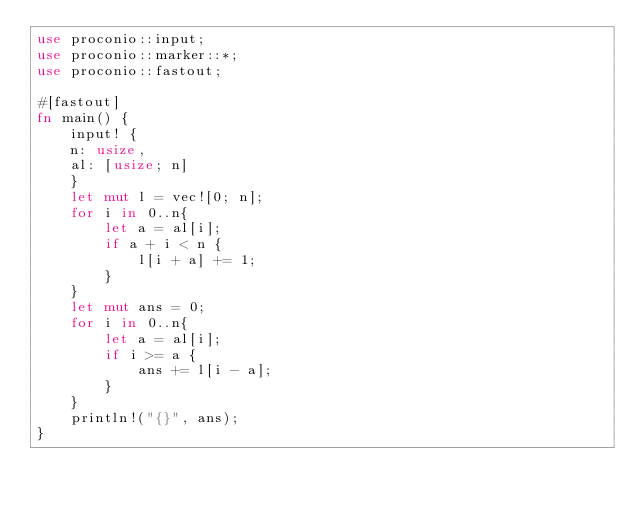Convert code to text. <code><loc_0><loc_0><loc_500><loc_500><_Rust_>use proconio::input;
use proconio::marker::*;
use proconio::fastout;

#[fastout]
fn main() {
    input! {
    n: usize,
    al: [usize; n]
    }
    let mut l = vec![0; n];
    for i in 0..n{
        let a = al[i];
        if a + i < n {
            l[i + a] += 1;
        }
    }
    let mut ans = 0;
    for i in 0..n{
        let a = al[i];
        if i >= a {
            ans += l[i - a];
        }
    }
    println!("{}", ans);
}
</code> 